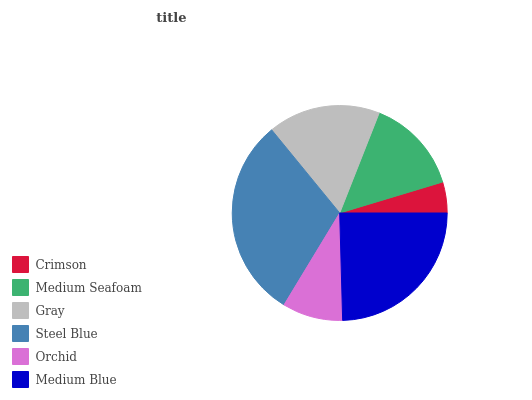Is Crimson the minimum?
Answer yes or no. Yes. Is Steel Blue the maximum?
Answer yes or no. Yes. Is Medium Seafoam the minimum?
Answer yes or no. No. Is Medium Seafoam the maximum?
Answer yes or no. No. Is Medium Seafoam greater than Crimson?
Answer yes or no. Yes. Is Crimson less than Medium Seafoam?
Answer yes or no. Yes. Is Crimson greater than Medium Seafoam?
Answer yes or no. No. Is Medium Seafoam less than Crimson?
Answer yes or no. No. Is Gray the high median?
Answer yes or no. Yes. Is Medium Seafoam the low median?
Answer yes or no. Yes. Is Crimson the high median?
Answer yes or no. No. Is Gray the low median?
Answer yes or no. No. 